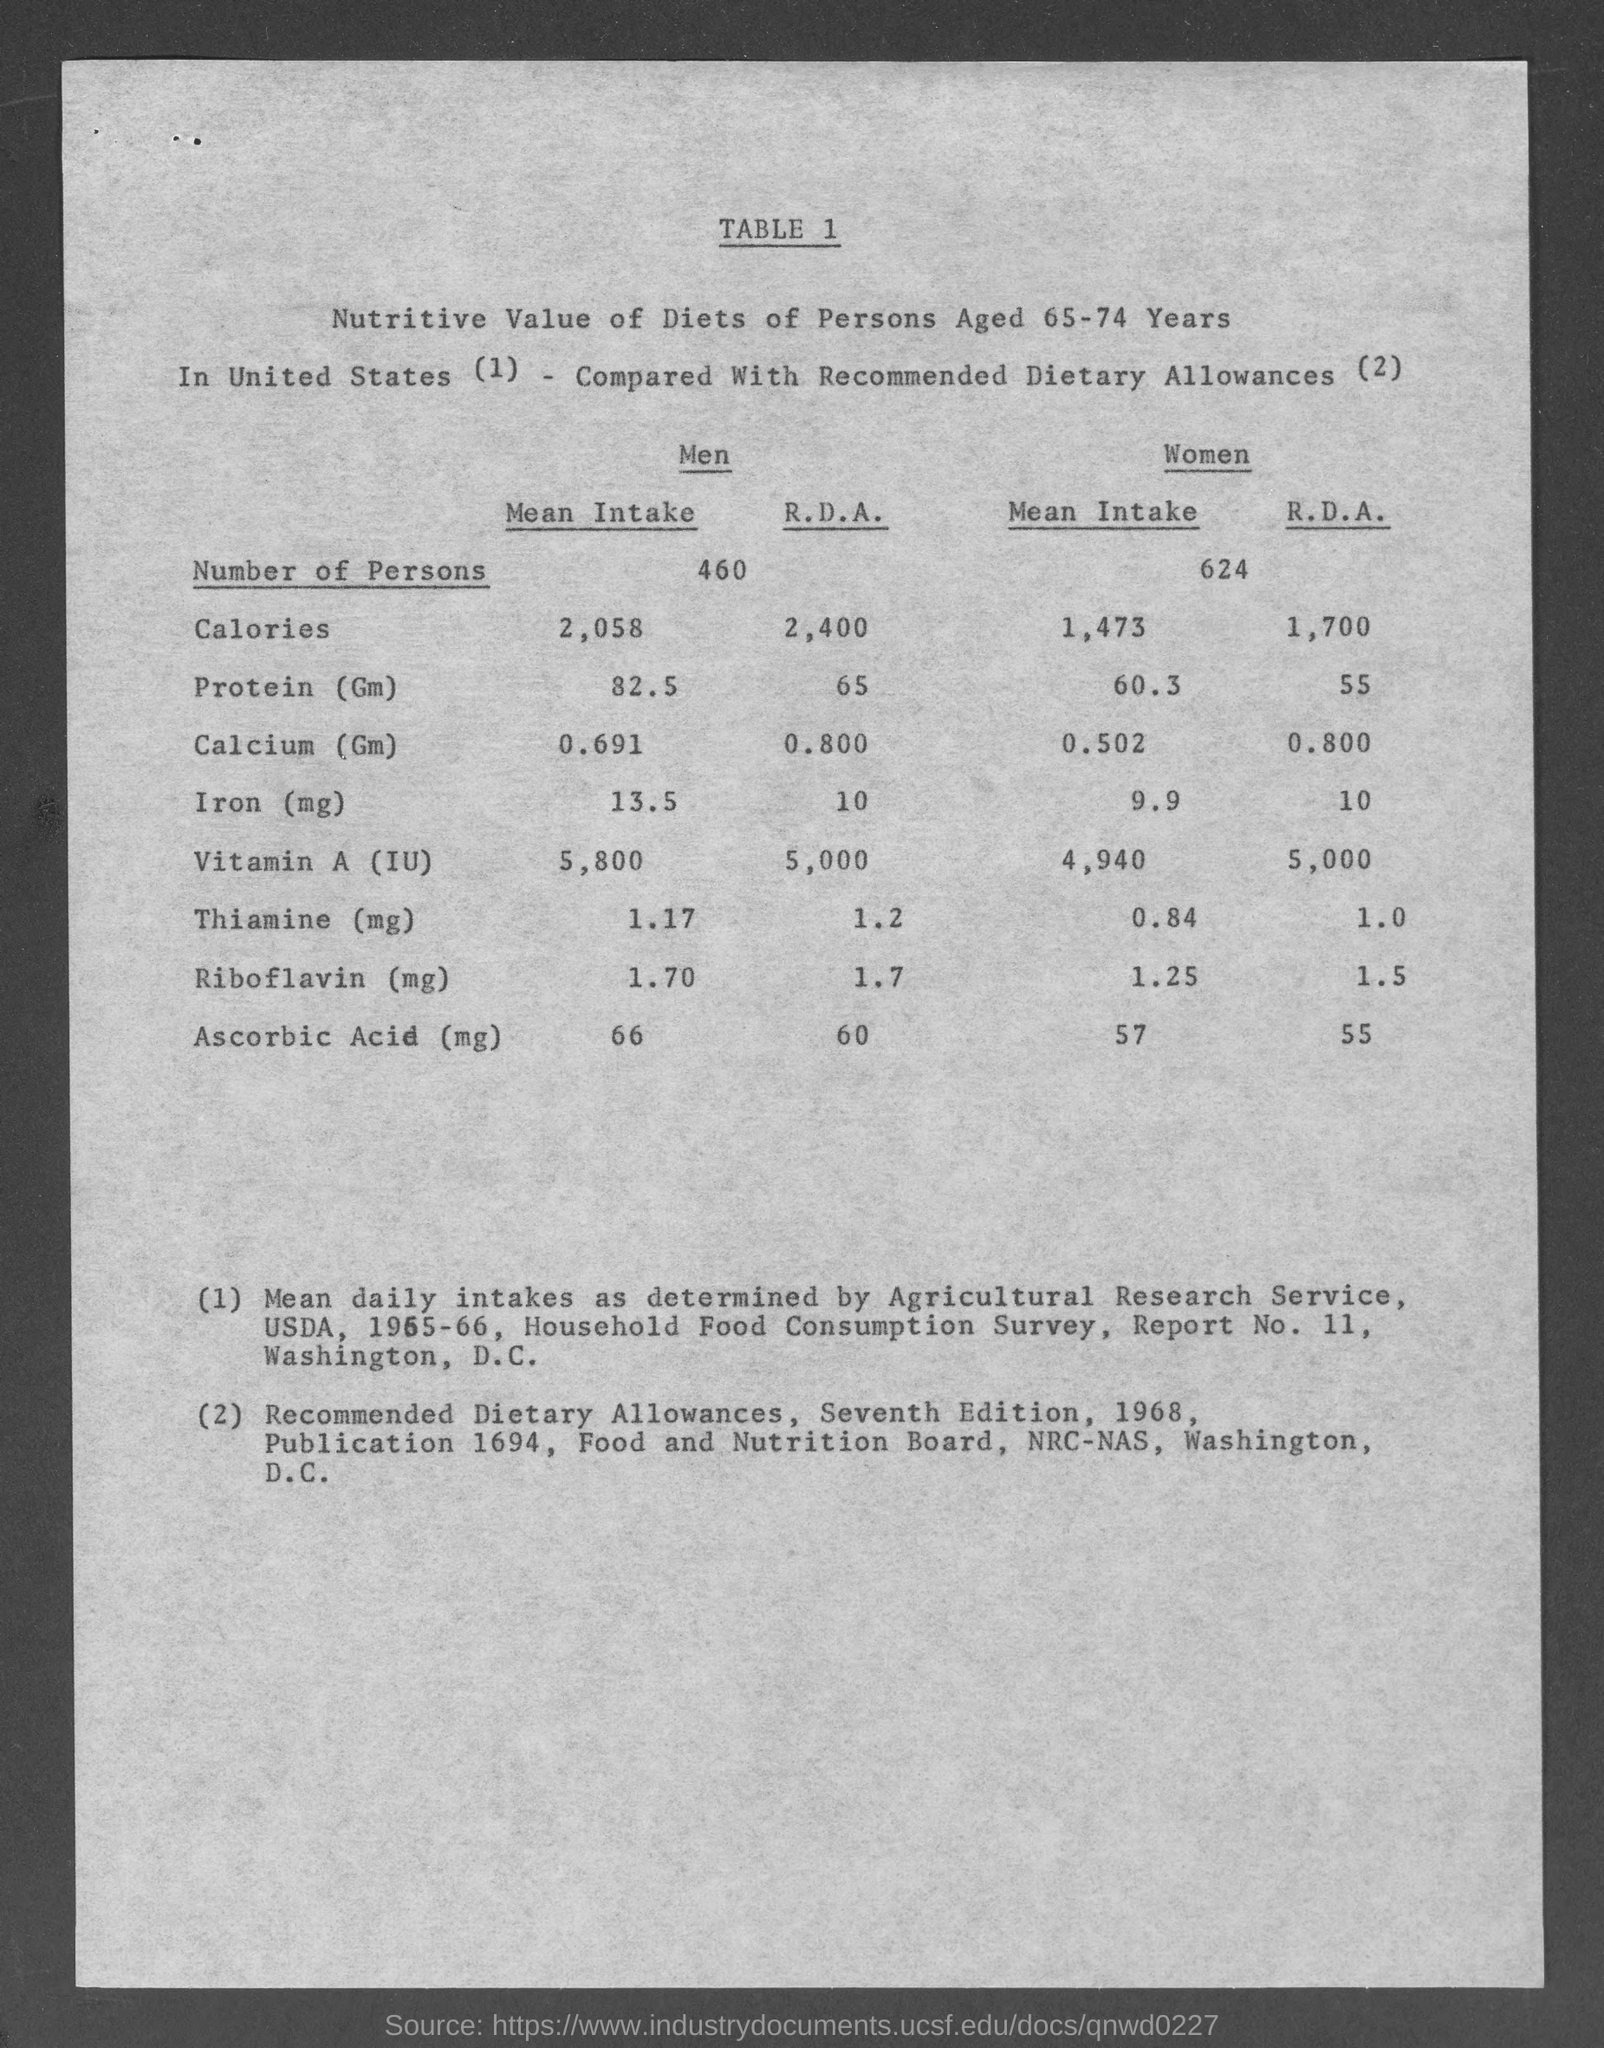Number of Men?
Ensure brevity in your answer.  460. Number of Women?
Keep it short and to the point. 624. What is the Mean Intake of Calcium(Gm) in Women?
Ensure brevity in your answer.  0.502. 